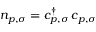Convert formula to latex. <formula><loc_0><loc_0><loc_500><loc_500>n _ { p , \sigma } = c _ { p , \sigma } ^ { \dagger } \, c _ { p , \sigma }</formula> 